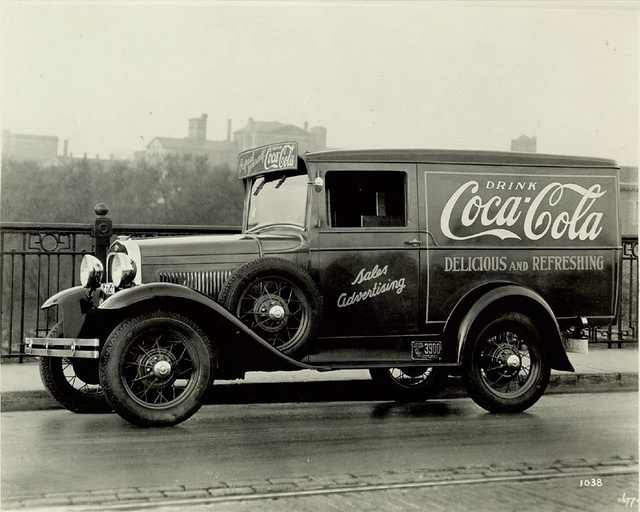Describe the objects in this image and their specific colors. I can see car in beige, black, gray, and darkgray tones and truck in beige, black, gray, and darkgray tones in this image. 